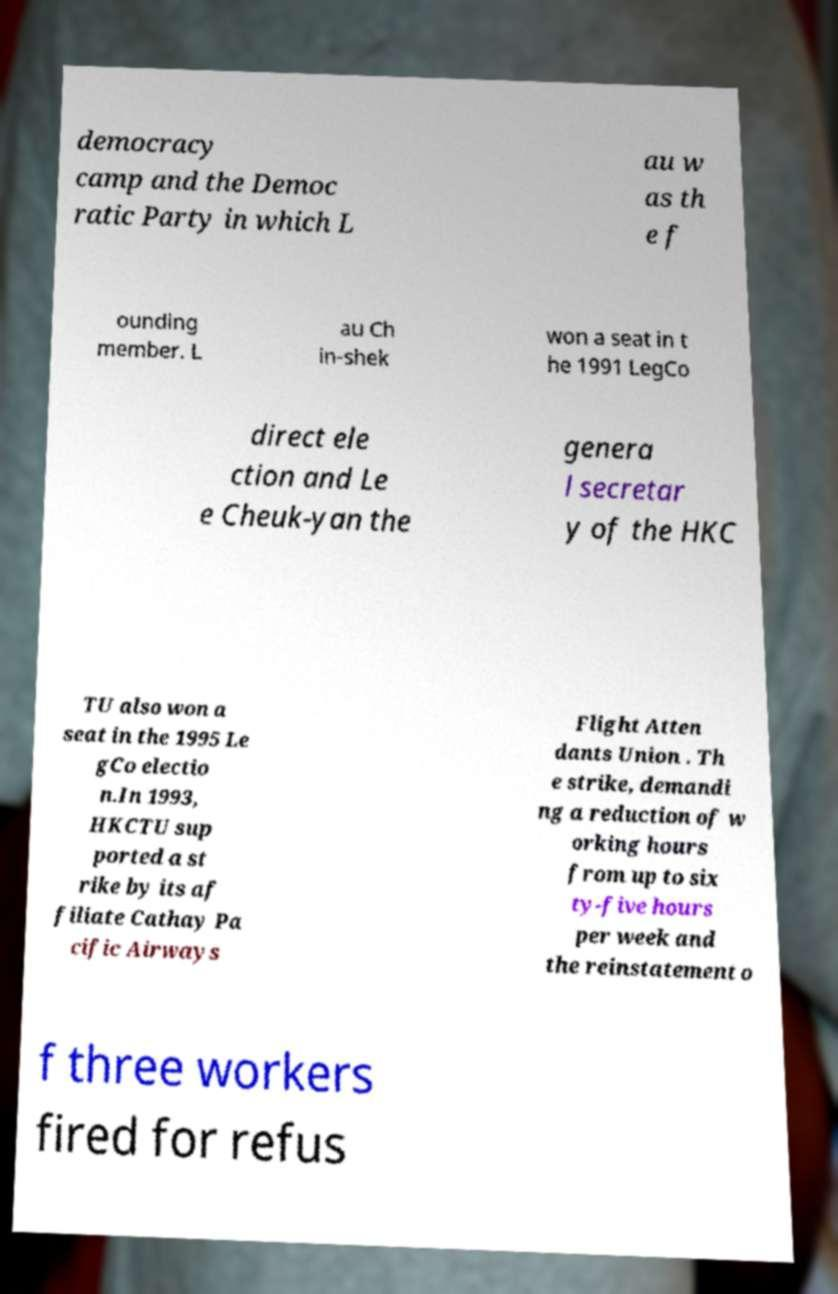Could you assist in decoding the text presented in this image and type it out clearly? democracy camp and the Democ ratic Party in which L au w as th e f ounding member. L au Ch in-shek won a seat in t he 1991 LegCo direct ele ction and Le e Cheuk-yan the genera l secretar y of the HKC TU also won a seat in the 1995 Le gCo electio n.In 1993, HKCTU sup ported a st rike by its af filiate Cathay Pa cific Airways Flight Atten dants Union . Th e strike, demandi ng a reduction of w orking hours from up to six ty-five hours per week and the reinstatement o f three workers fired for refus 